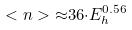Convert formula to latex. <formula><loc_0><loc_0><loc_500><loc_500>< n > { \approx } 3 6 { \cdot } E ^ { 0 . 5 6 } _ { h }</formula> 